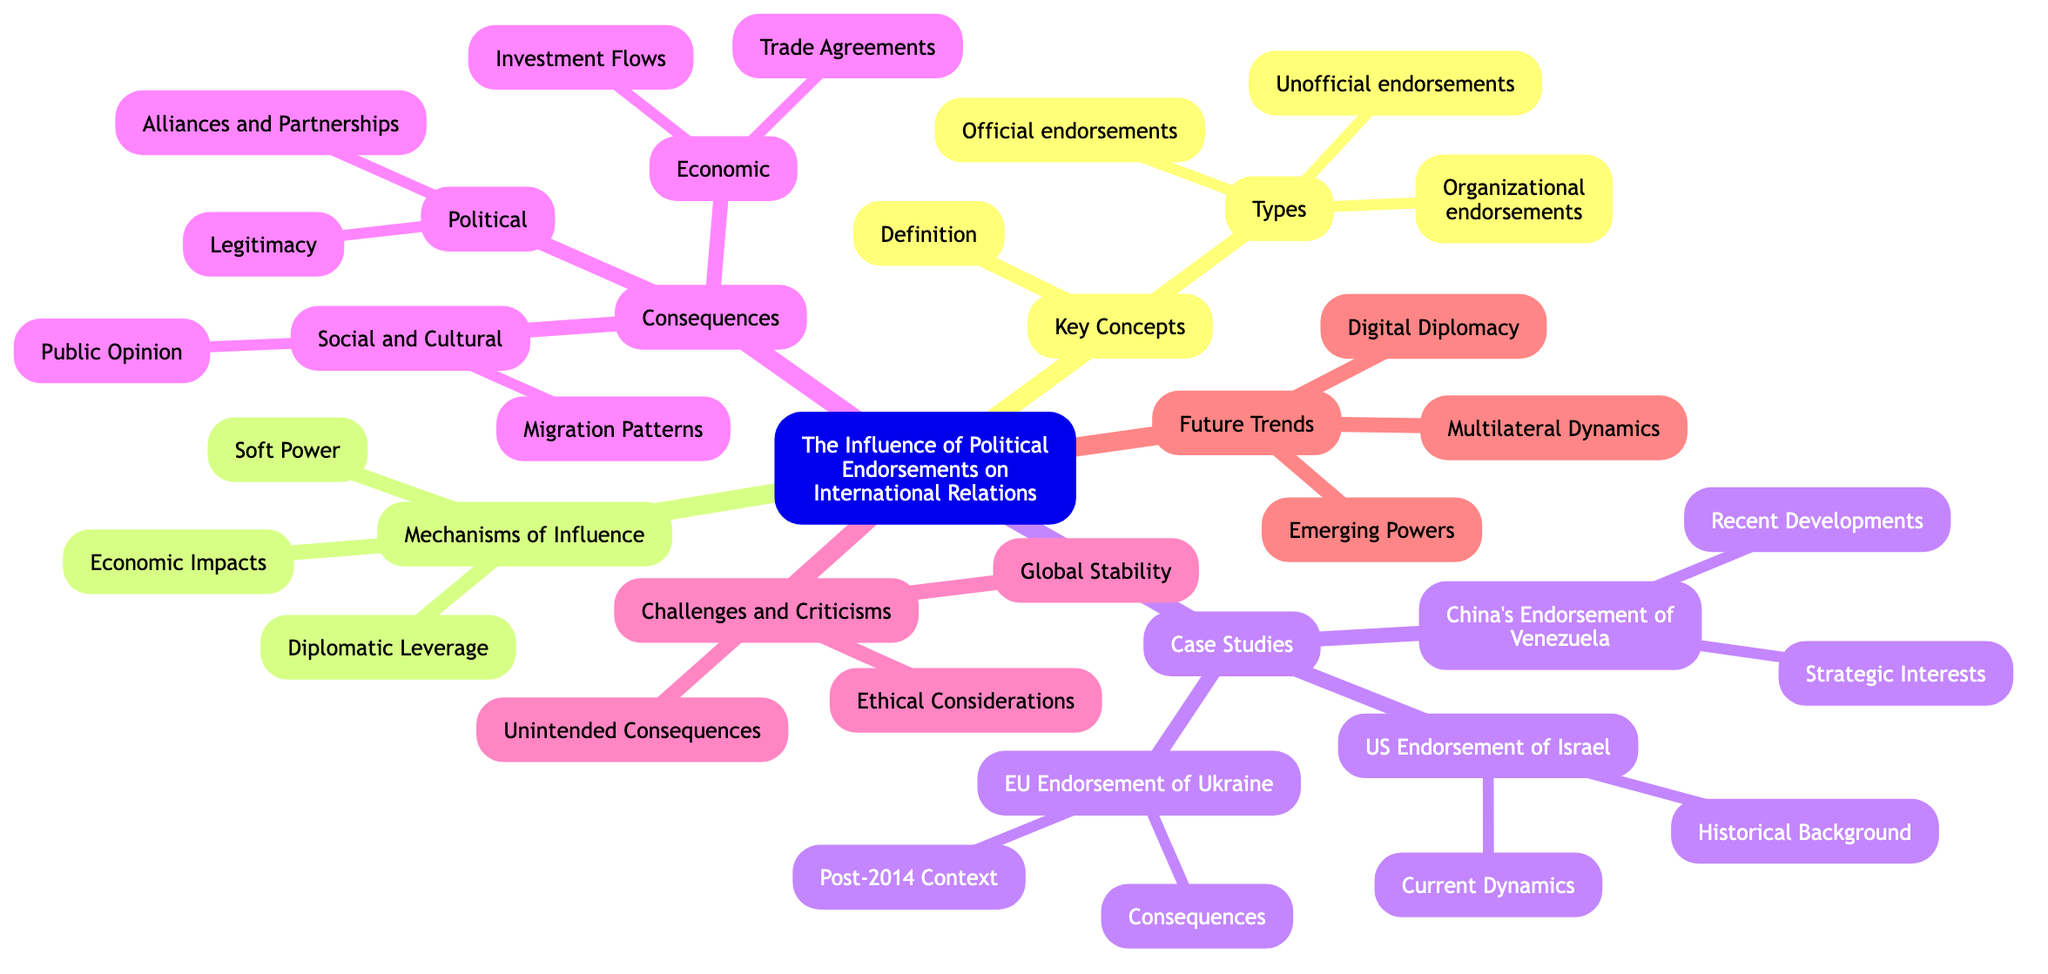What are the types of political endorsements listed in the diagram? The diagram lists three types of political endorsements: official endorsements, unofficial endorsements, and organizational endorsements. These categories are directly under the "Types" node in the "Key Concepts" section.
Answer: official endorsements, unofficial endorsements, organizational endorsements What are the consequences of political endorsements mentioned in the mind map? The consequences of political endorsements include political consequences, economic consequences, and social and cultural consequences. These broader categories can be found as main nodes under the "Consequences" section.
Answer: political, economic, social and cultural How many case studies are presented in the diagram? The diagram presents three case studies: US Endorsement of Israel, China’s Endorsement of Venezuela, and EU Endorsement of Ukraine. These are listed directly under the "Case Studies" node, which indicates their count.
Answer: 3 What is a mechanism of influence connected to political endorsements? One mechanism of influence connected to political endorsements is "Soft Power," which is directly listed under the "Mechanisms of Influence" section. This indicates forms of influence that do not involve coercion.
Answer: Soft Power How does the EU endorsement of Ukraine affect its consequences? The EU endorsement of Ukraine has consequences related to political reforms and the EU-Ukraine Association Agreement, as highlighted in the specific case study regarding Ukraine under the "Case Studies" section.
Answer: Political reforms, EU-Ukraine Association Agreement What issues are categorized under challenges and criticisms? The issues categorized under challenges and criticisms include ethical considerations, unintended consequences, and global stability. These categories are directly listed in the "Challenges and Criticisms" section.
Answer: ethical considerations, unintended consequences, global stability Which future trend involves the increasing role of technology? The future trend that involves the increasing role of technology in political endorsements is "Digital Diplomacy," as identified in the "Future Trends" section of the diagram.
Answer: Digital Diplomacy What aspect of international relations is influenced by public opinion? Public opinion influences the social and cultural consequences of political endorsements, specifically regarding shifts in public perception of international entities, as noted in the "Social and Cultural" category under "Consequences."
Answer: shifts in public perception 